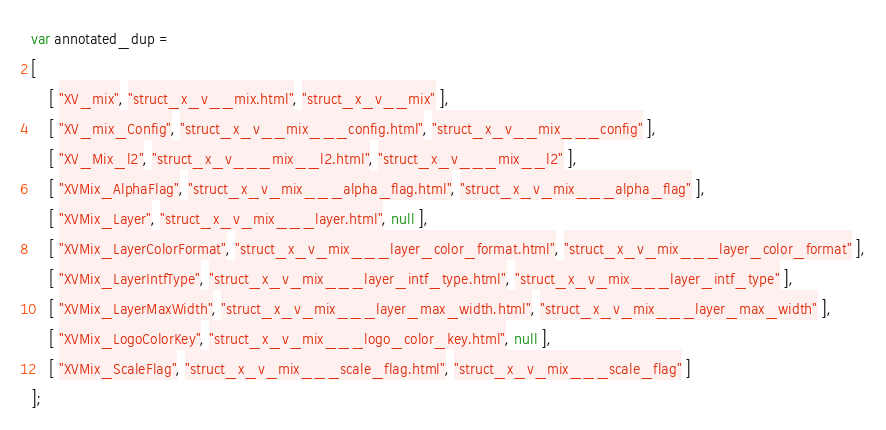<code> <loc_0><loc_0><loc_500><loc_500><_JavaScript_>var annotated_dup =
[
    [ "XV_mix", "struct_x_v__mix.html", "struct_x_v__mix" ],
    [ "XV_mix_Config", "struct_x_v__mix___config.html", "struct_x_v__mix___config" ],
    [ "XV_Mix_l2", "struct_x_v___mix__l2.html", "struct_x_v___mix__l2" ],
    [ "XVMix_AlphaFlag", "struct_x_v_mix___alpha_flag.html", "struct_x_v_mix___alpha_flag" ],
    [ "XVMix_Layer", "struct_x_v_mix___layer.html", null ],
    [ "XVMix_LayerColorFormat", "struct_x_v_mix___layer_color_format.html", "struct_x_v_mix___layer_color_format" ],
    [ "XVMix_LayerIntfType", "struct_x_v_mix___layer_intf_type.html", "struct_x_v_mix___layer_intf_type" ],
    [ "XVMix_LayerMaxWidth", "struct_x_v_mix___layer_max_width.html", "struct_x_v_mix___layer_max_width" ],
    [ "XVMix_LogoColorKey", "struct_x_v_mix___logo_color_key.html", null ],
    [ "XVMix_ScaleFlag", "struct_x_v_mix___scale_flag.html", "struct_x_v_mix___scale_flag" ]
];</code> 